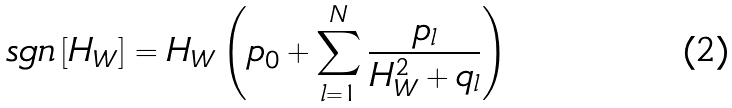Convert formula to latex. <formula><loc_0><loc_0><loc_500><loc_500>s g n \left [ H _ { W } \right ] = H _ { W } \left ( p _ { 0 } + \sum _ { l = 1 } ^ { N } \frac { p _ { l } } { H _ { W } ^ { 2 } + q _ { l } } \right )</formula> 